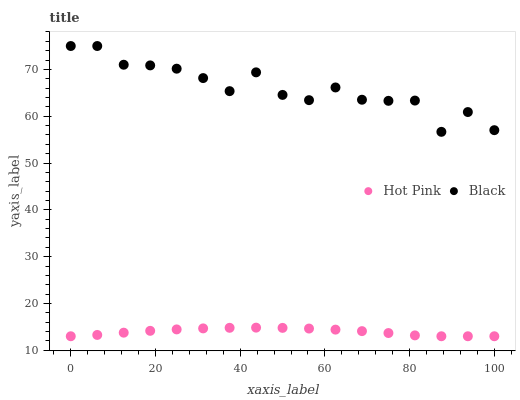Does Hot Pink have the minimum area under the curve?
Answer yes or no. Yes. Does Black have the maximum area under the curve?
Answer yes or no. Yes. Does Black have the minimum area under the curve?
Answer yes or no. No. Is Hot Pink the smoothest?
Answer yes or no. Yes. Is Black the roughest?
Answer yes or no. Yes. Is Black the smoothest?
Answer yes or no. No. Does Hot Pink have the lowest value?
Answer yes or no. Yes. Does Black have the lowest value?
Answer yes or no. No. Does Black have the highest value?
Answer yes or no. Yes. Is Hot Pink less than Black?
Answer yes or no. Yes. Is Black greater than Hot Pink?
Answer yes or no. Yes. Does Hot Pink intersect Black?
Answer yes or no. No. 